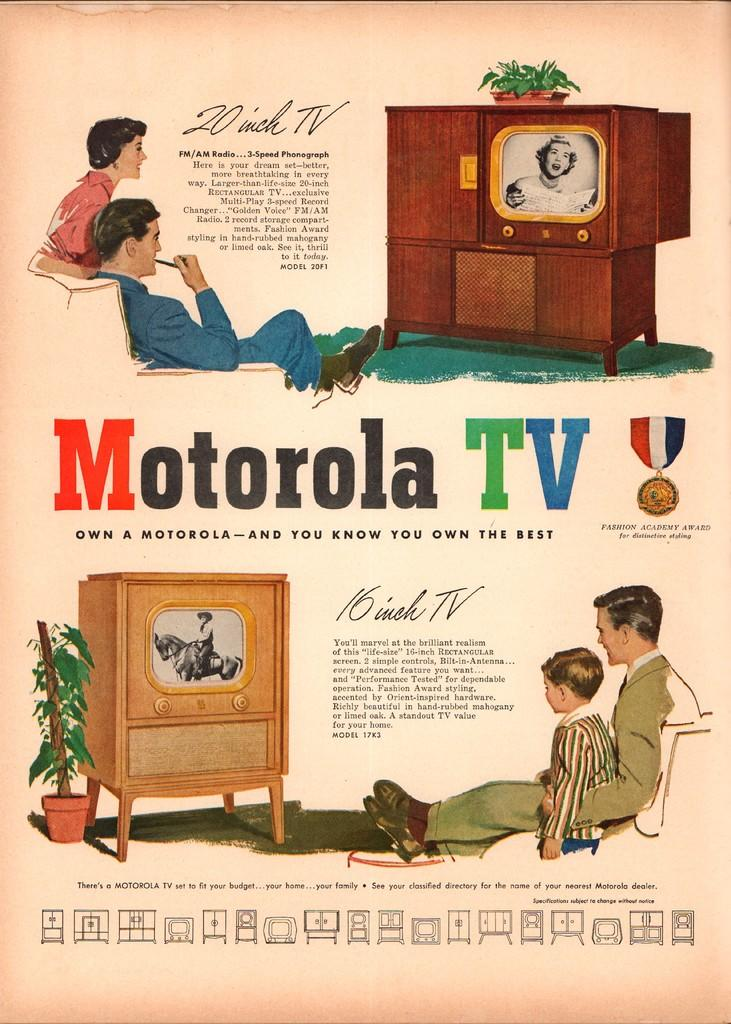What is present on the poster in the image? There is a poster in the image that contains pictures and text. Can you describe the content of the poster? The poster contains pictures and text, but the specific content cannot be determined from the provided facts. What type of orange can be seen in the poster? There is no orange present in the image, as the poster contains pictures and text, but no specific content is mentioned. How many deer are depicted in the poster? There is no deer present in the poster, as the poster contains pictures and text, but no specific content is mentioned. 